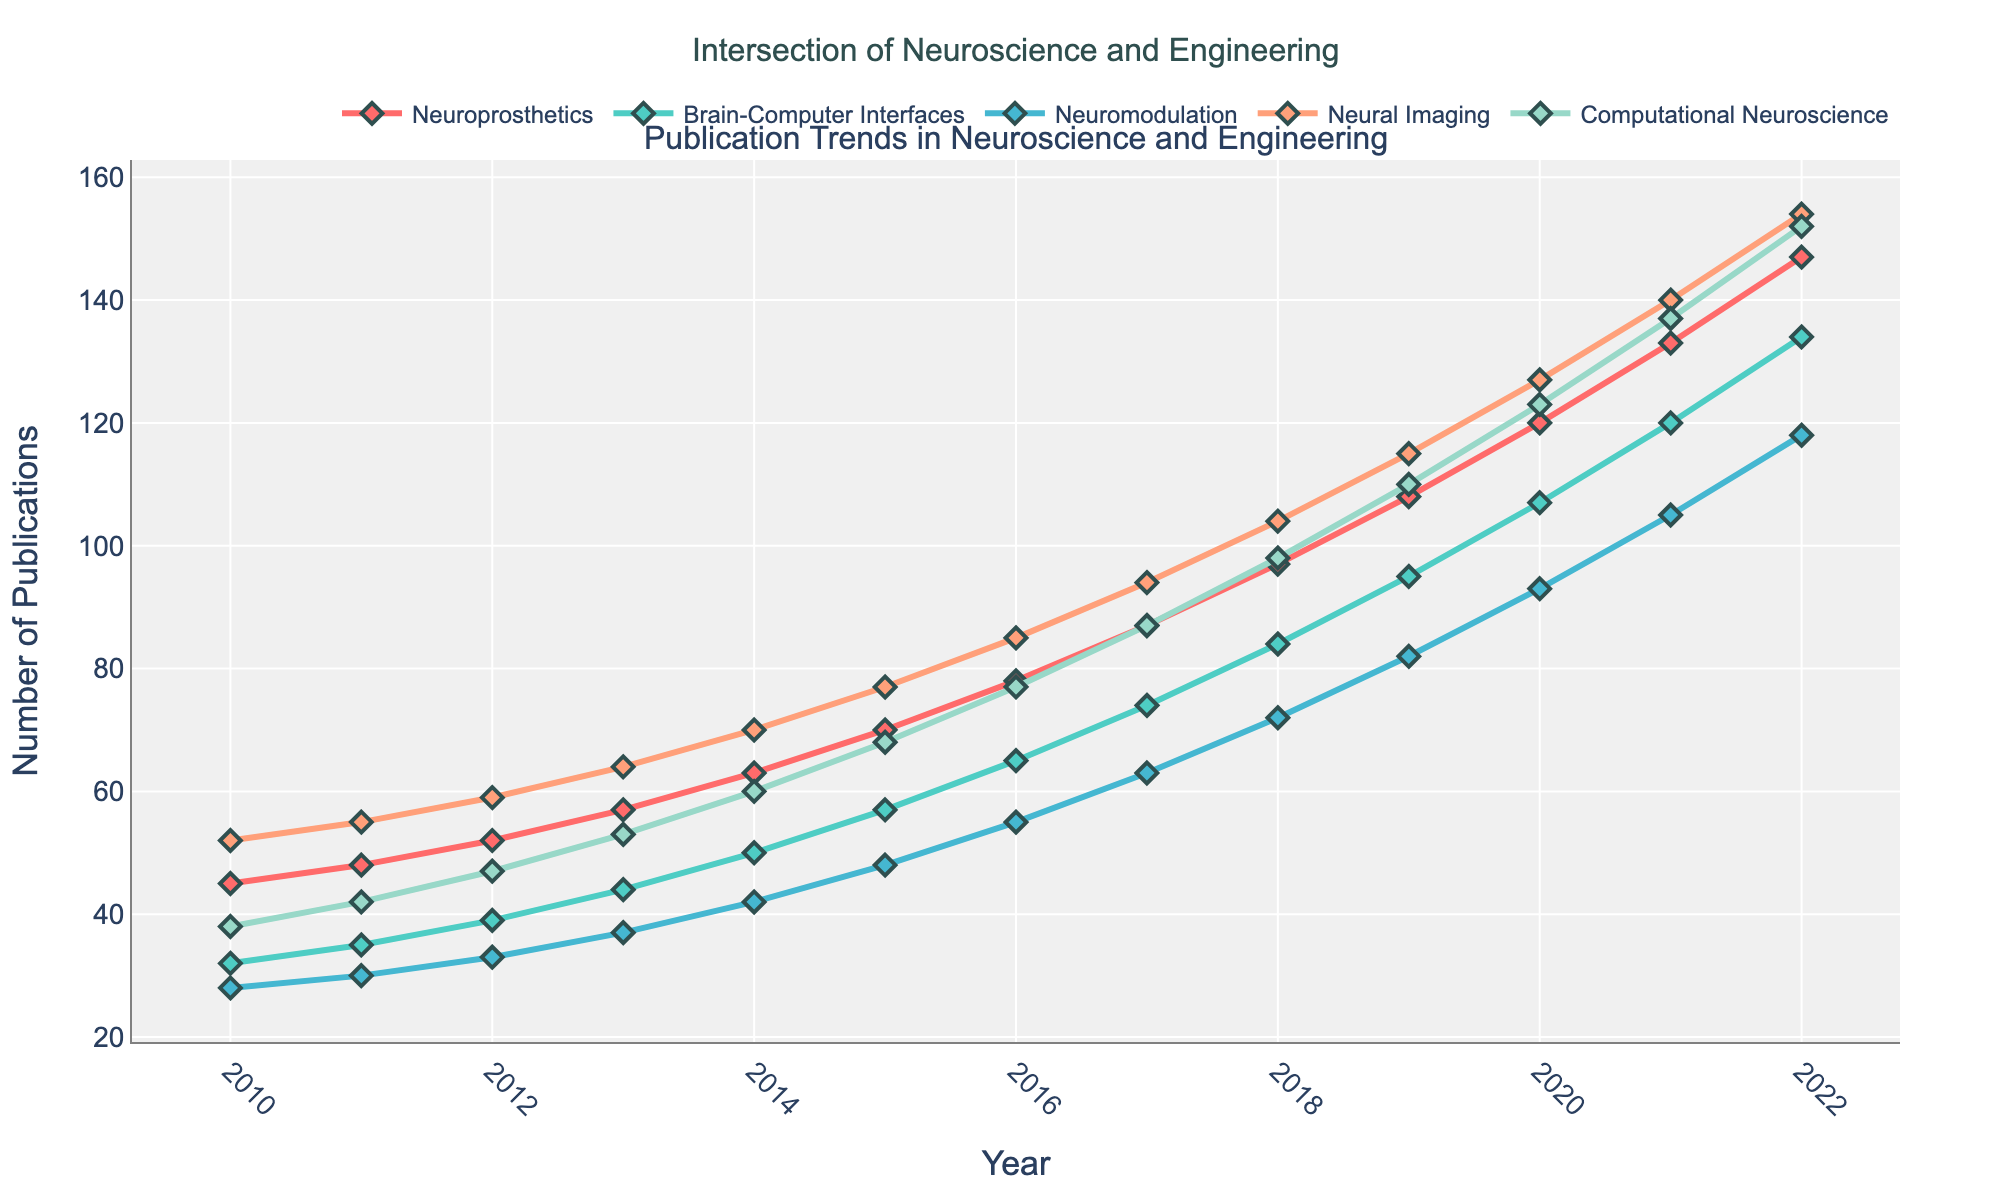What's the general trend for publications in all subfields from 2010 to 2022? By looking at the line chart, all subfields show an increasing trend in the number of publications from 2010 to 2022.
Answer: Increasing Trend Which subfield had the highest number of publications in 2022? By checking the values at the year 2022 for all subfields, Neural Imaging had 154 publications, which is the highest.
Answer: Neural Imaging Which subfield had the slowest growth rate over the period from 2010 to 2022? By comparing the slopes of the lines, Neuromodulation shows the least steep slope, indicating the slowest growth rate.
Answer: Neuromodulation In what year did Brain-Computer Interfaces surpass 100 publications? By locating the point on the Brain-Computer Interfaces line, it surpassed 100 publications in 2020.
Answer: 2020 What's the difference in the number of publications between Computational Neuroscience and Neuroprosthetics in 2022? The number of publications in Computational Neuroscience is 152 and in Neuroprosthetics is 147. The difference is 152 - 147 = 5.
Answer: 5 By how much did the number of publications in Neural Imaging increase from 2010 to 2022? The number of publications in Neural Imaging in 2010 was 52, and in 2022 it is 154. The increase is 154 - 52 = 102.
Answer: 102 Which two subfields showed the closest number of publications in 2015? By visually comparing the points in 2015, Brain-Computer Interfaces and Computational Neuroscience have 57 and 68 publications respectively, the closest among all pairs.
Answer: Brain-Computer Interfaces and Computational Neuroscience What's the average number of publications in the Neuroprosthetics subfield for the years 2010 and 2022? The number of publications in Neuroprosthetics in 2010 is 45 and in 2022 is 147. The average is (45 + 147) / 2 = 96.
Answer: 96 Compare the growth between Brain-Computer Interfaces and Neuromodulation from 2010 to 2022. Which one grew more? Brain-Computer Interfaces grew from 32 to 134, an increase of 134 - 32 = 102. Neuromodulation grew from 28 to 118, an increase of 118 - 28 = 90. Brain-Computer Interfaces grew more.
Answer: Brain-Computer Interfaces What's the ratio of publication numbers between Neuroprosthetics and Neural Imaging in 2017? The number of publications in Neuroprosthetics is 87 and in Neural Imaging is 94 in 2017. The ratio is 87 / 94 ≈ 0.925.
Answer: 0.925 